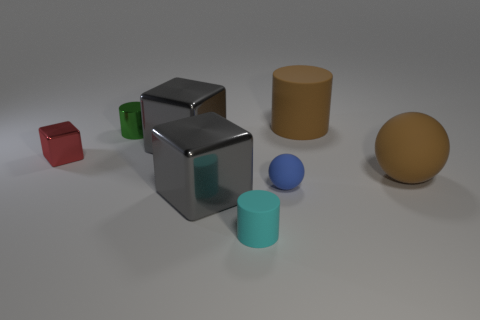Add 1 tiny red metallic things. How many objects exist? 9 Subtract all blocks. How many objects are left? 5 Subtract 0 red cylinders. How many objects are left? 8 Subtract all matte balls. Subtract all tiny blue rubber objects. How many objects are left? 5 Add 3 brown cylinders. How many brown cylinders are left? 4 Add 2 blocks. How many blocks exist? 5 